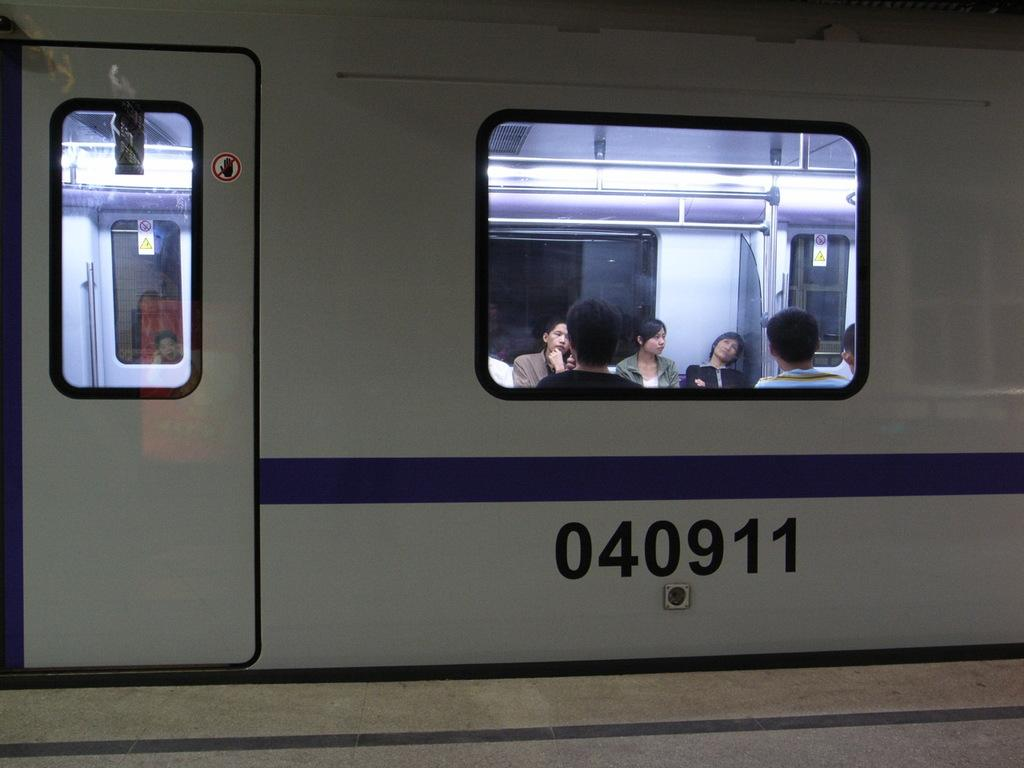What is the main subject of the image? The main subject of the image is a train. Can you describe any other elements in the image? Yes, there is a group of people visible in the image. How might the people be related to the train? The presence of a window glass suggests that the people are seen through a window, possibly observing the train. What grade does the creator of the train receive for their work in the image? There is no information about a creator or their grade in the image. The image simply shows a train and a group of people observing it. 